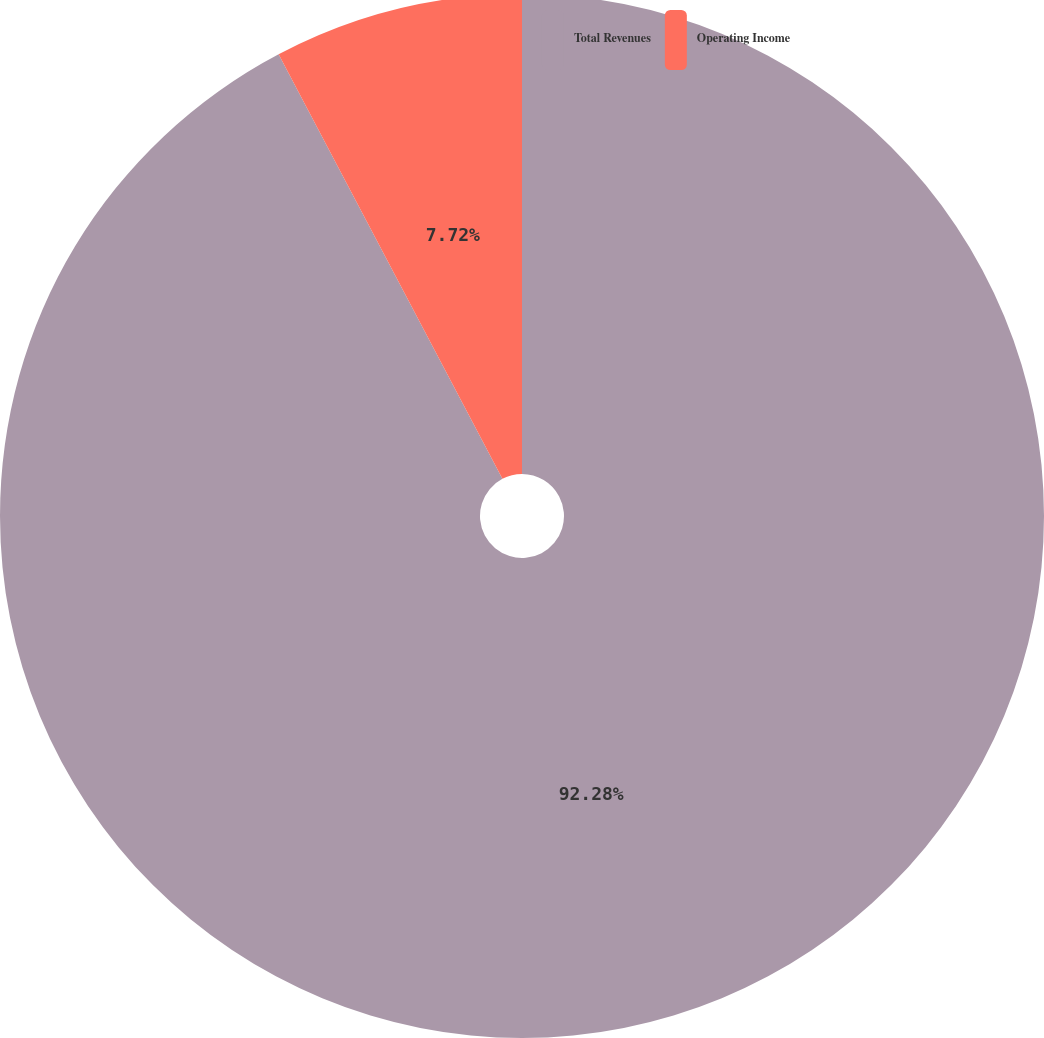<chart> <loc_0><loc_0><loc_500><loc_500><pie_chart><fcel>Total Revenues<fcel>Operating Income<nl><fcel>92.28%<fcel>7.72%<nl></chart> 